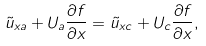Convert formula to latex. <formula><loc_0><loc_0><loc_500><loc_500>\tilde { u } _ { x a } + U _ { a } \frac { \partial f } { \partial x } = \tilde { u } _ { x c } + U _ { c } \frac { \partial f } { \partial x } ,</formula> 